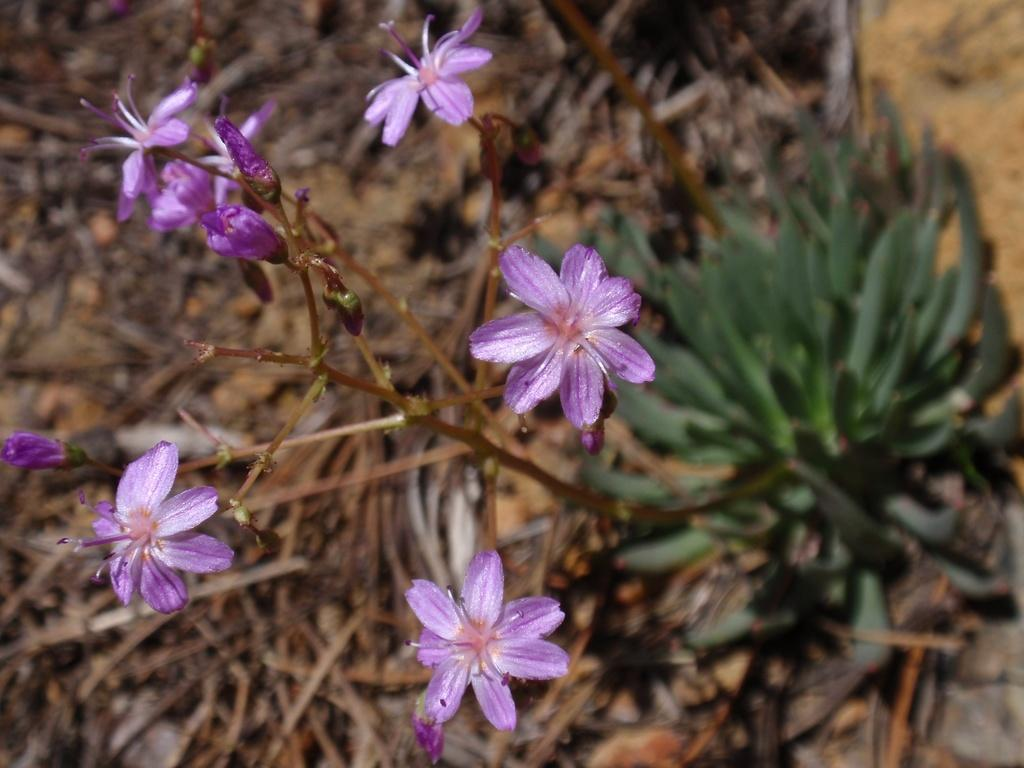What type of living organisms can be seen in the image? Plants and flowers are visible in the image. What color are the flowers in the image? The flowers in the image are in purple color. What material can be seen in the image? Wood is visible in the image. How many times does the person kick the square object in the image? There is no person or square object present in the image. 